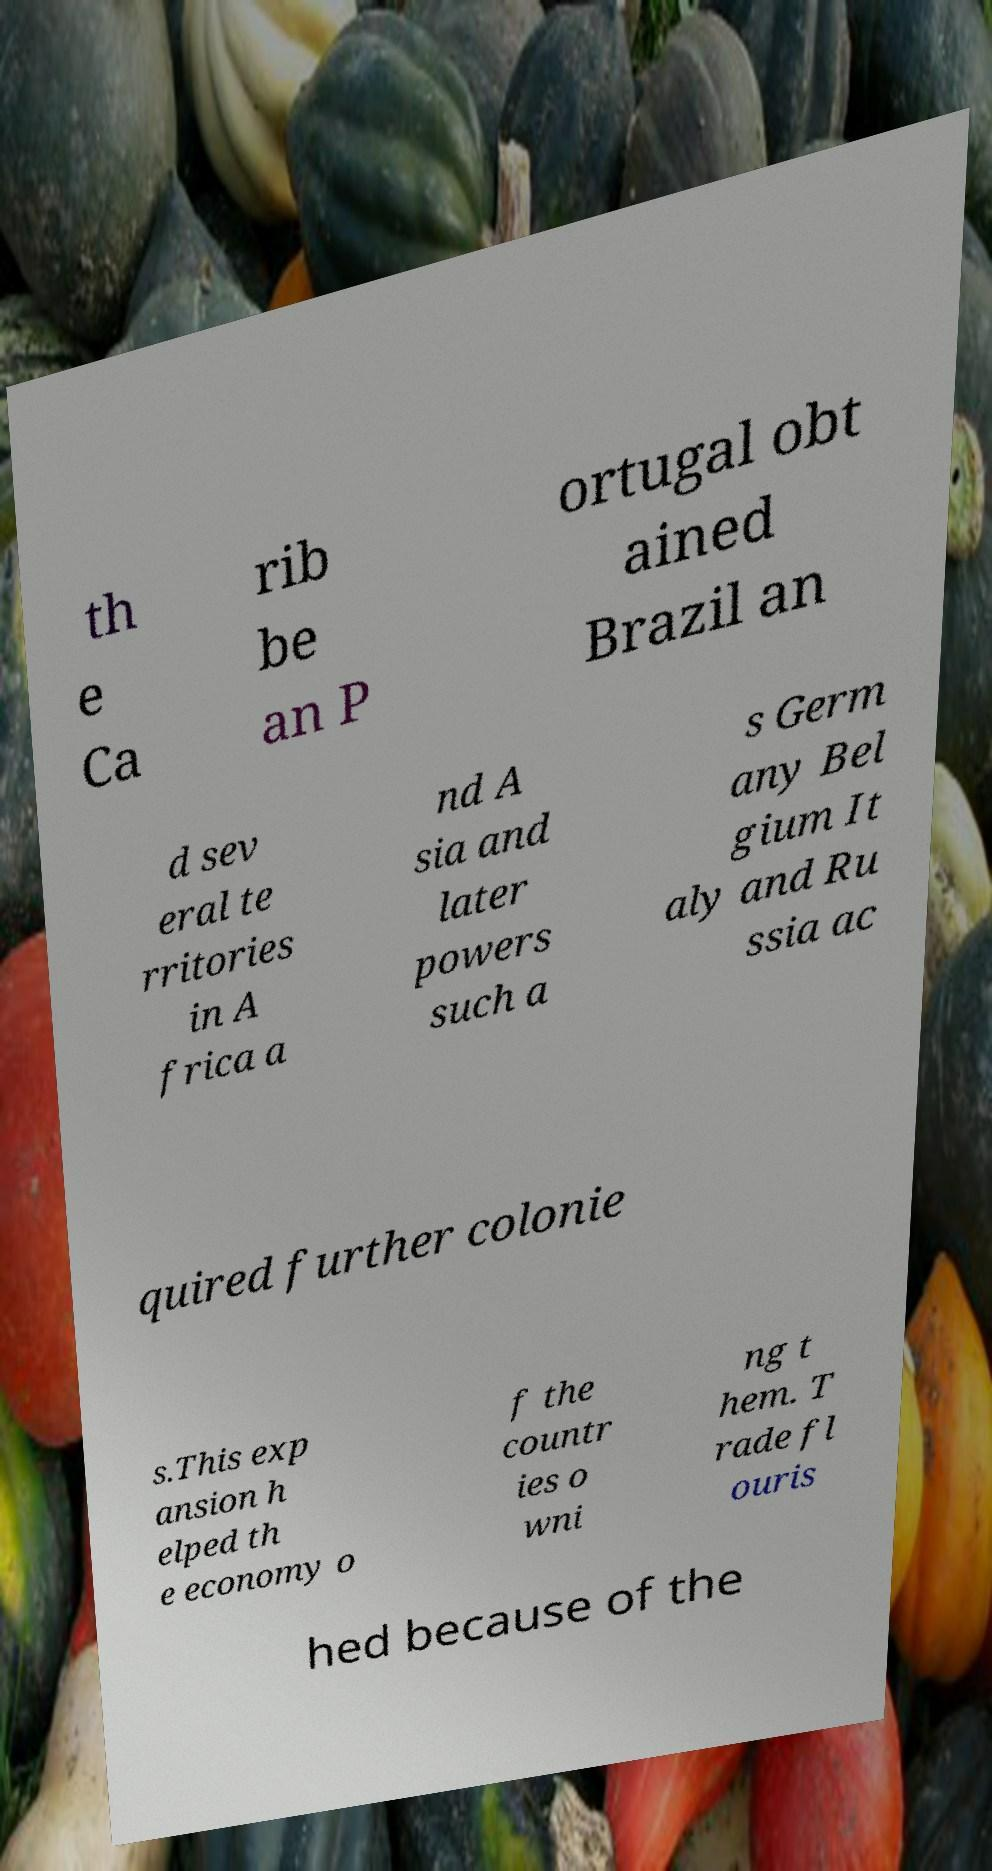I need the written content from this picture converted into text. Can you do that? th e Ca rib be an P ortugal obt ained Brazil an d sev eral te rritories in A frica a nd A sia and later powers such a s Germ any Bel gium It aly and Ru ssia ac quired further colonie s.This exp ansion h elped th e economy o f the countr ies o wni ng t hem. T rade fl ouris hed because of the 